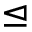Convert formula to latex. <formula><loc_0><loc_0><loc_500><loc_500>\triangleleft e q</formula> 